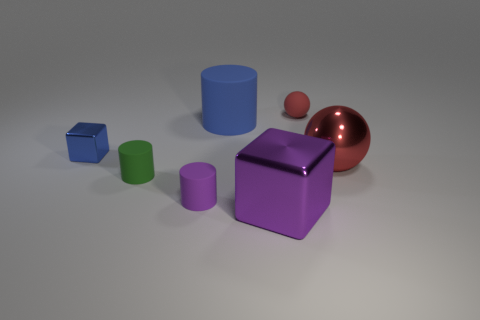Subtract all small rubber cylinders. How many cylinders are left? 1 Add 2 red objects. How many objects exist? 9 Subtract all blue cylinders. How many cylinders are left? 2 Subtract all blocks. How many objects are left? 5 Subtract 0 gray balls. How many objects are left? 7 Subtract 2 cylinders. How many cylinders are left? 1 Subtract all green blocks. Subtract all red balls. How many blocks are left? 2 Subtract all large green cylinders. Subtract all big red metal balls. How many objects are left? 6 Add 2 green cylinders. How many green cylinders are left? 3 Add 1 cylinders. How many cylinders exist? 4 